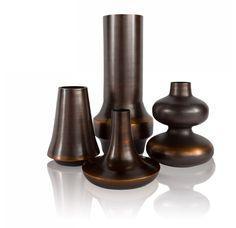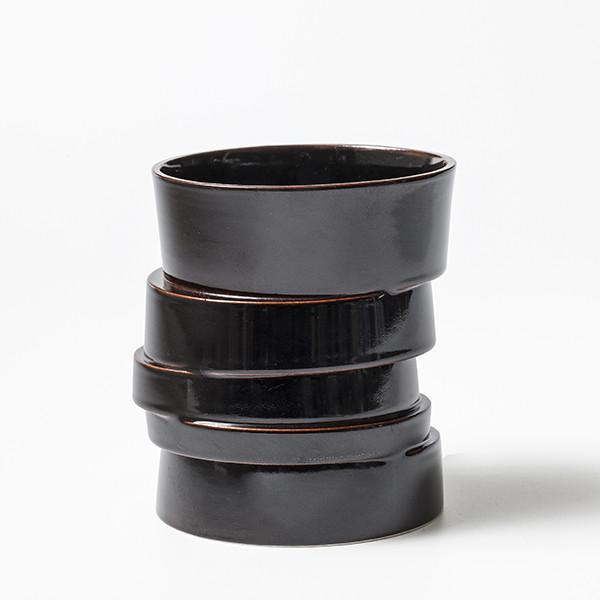The first image is the image on the left, the second image is the image on the right. For the images shown, is this caption "At least one of the vases contains a plant with leaves." true? Answer yes or no. No. 